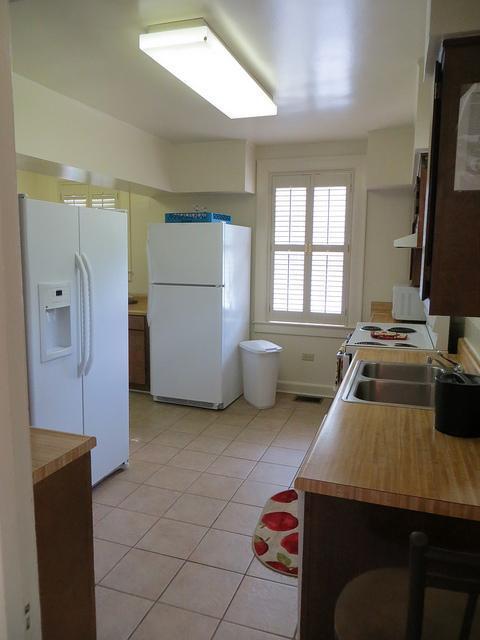How many windows are there?
Give a very brief answer. 1. How many rugs are on the floor?
Give a very brief answer. 1. How many handles on the cabinets are visible?
Give a very brief answer. 0. How many chairs are in the photo?
Give a very brief answer. 1. How many refrigerators can you see?
Give a very brief answer. 2. How many motorcycles are in the picture?
Give a very brief answer. 0. 